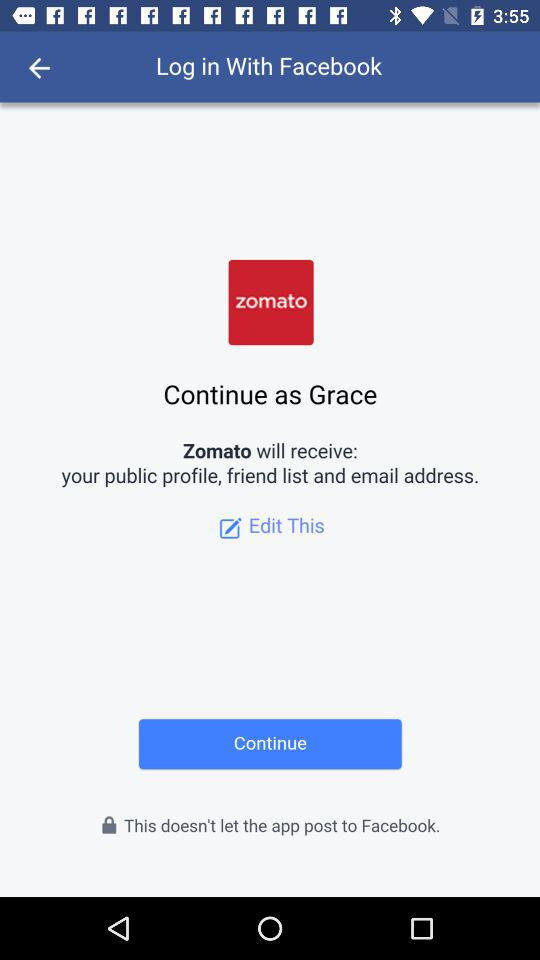What application can be used to log in to the profile? The application that can be used to log in is "Facebook". 